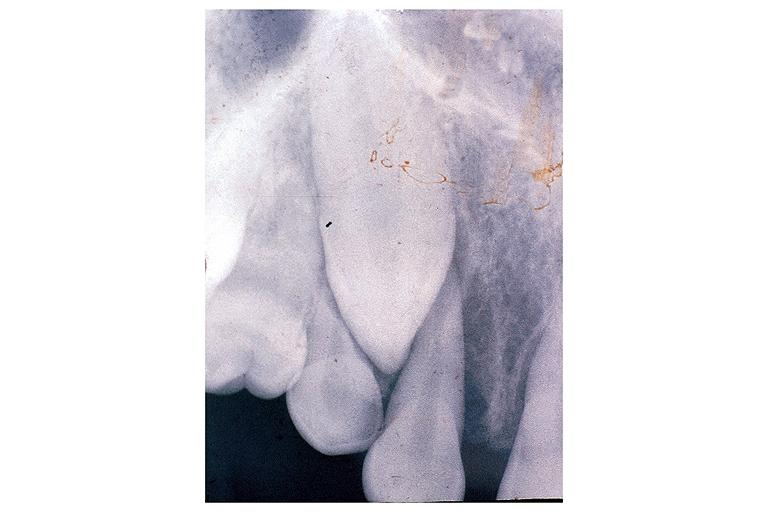s oral present?
Answer the question using a single word or phrase. Yes 